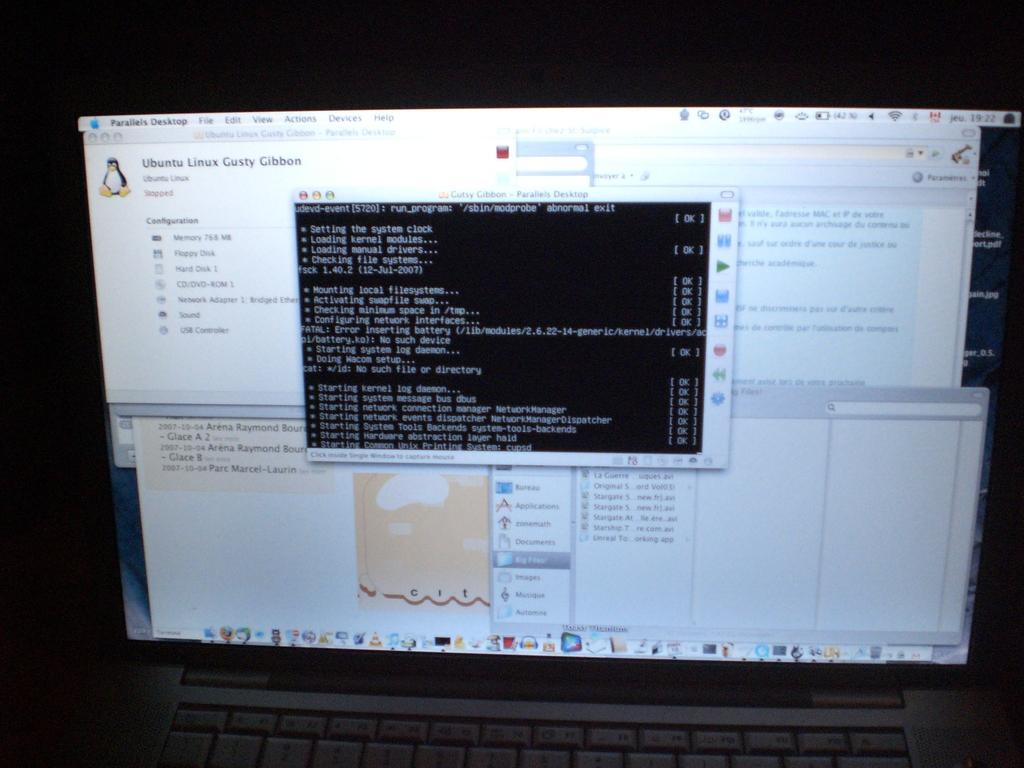<image>
Create a compact narrative representing the image presented. the computer monitor is open to a page with the word Ubuntu at the top corner 